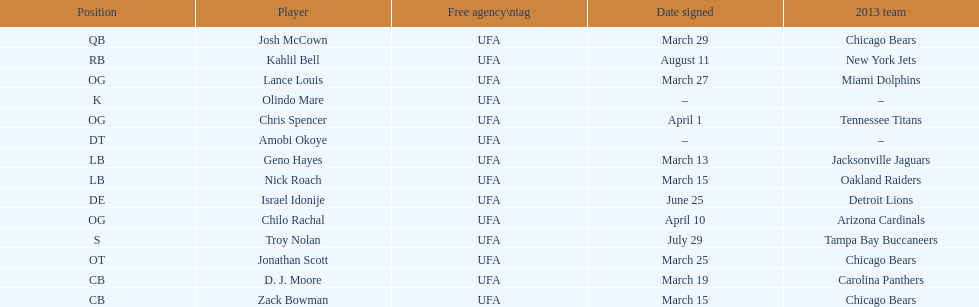Geno hayes and nick roach both played which position? LB. 